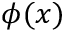Convert formula to latex. <formula><loc_0><loc_0><loc_500><loc_500>\phi ( x )</formula> 